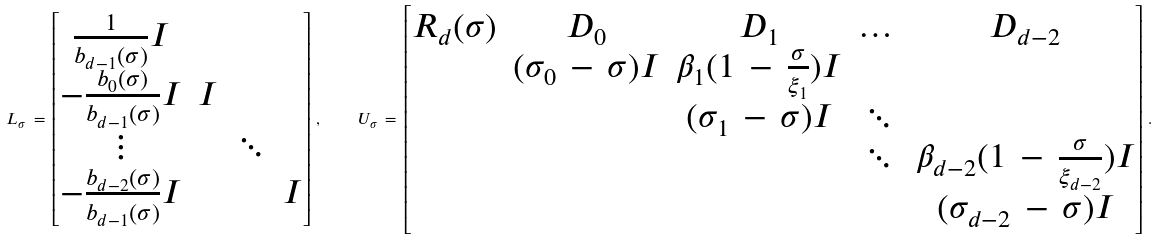Convert formula to latex. <formula><loc_0><loc_0><loc_500><loc_500>L _ { \sigma } \, = \, \begin{bmatrix} \frac { 1 } { b _ { d - 1 } ( \sigma ) } I & & & \\ - \frac { b _ { 0 } ( \sigma ) } { b _ { d - 1 } ( \sigma ) } I & I & & \\ \vdots & & \ddots & \\ - \frac { b _ { d - 2 } ( \sigma ) } { b _ { d - 1 } ( \sigma ) } I & & & I \end{bmatrix} \, , \quad U _ { \sigma } \, = \, \begin{bmatrix} R _ { d } ( \sigma ) & D _ { 0 } & D _ { 1 } & \dots & D _ { d - 2 } \\ & ( \sigma _ { 0 } \, - \, \sigma ) I & \beta _ { 1 } ( 1 \, - \, \frac { \sigma } { \xi _ { 1 } } ) I & & \\ & & ( \sigma _ { 1 } \, - \, \sigma ) I & \ddots & \\ & & & \ddots & \beta _ { d - 2 } ( 1 \, - \, \frac { \sigma } { \xi _ { d - 2 } } ) I \\ & & & & ( \sigma _ { d - 2 } \, - \, \sigma ) I \end{bmatrix} \, .</formula> 